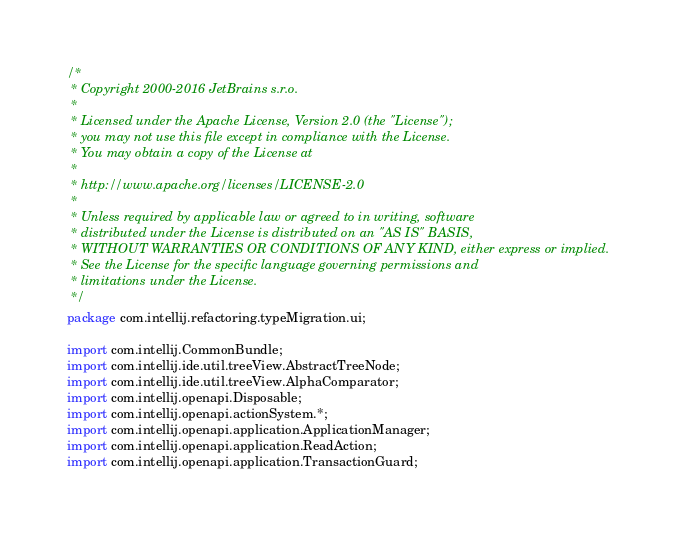<code> <loc_0><loc_0><loc_500><loc_500><_Java_>/*
 * Copyright 2000-2016 JetBrains s.r.o.
 *
 * Licensed under the Apache License, Version 2.0 (the "License");
 * you may not use this file except in compliance with the License.
 * You may obtain a copy of the License at
 *
 * http://www.apache.org/licenses/LICENSE-2.0
 *
 * Unless required by applicable law or agreed to in writing, software
 * distributed under the License is distributed on an "AS IS" BASIS,
 * WITHOUT WARRANTIES OR CONDITIONS OF ANY KIND, either express or implied.
 * See the License for the specific language governing permissions and
 * limitations under the License.
 */
package com.intellij.refactoring.typeMigration.ui;

import com.intellij.CommonBundle;
import com.intellij.ide.util.treeView.AbstractTreeNode;
import com.intellij.ide.util.treeView.AlphaComparator;
import com.intellij.openapi.Disposable;
import com.intellij.openapi.actionSystem.*;
import com.intellij.openapi.application.ApplicationManager;
import com.intellij.openapi.application.ReadAction;
import com.intellij.openapi.application.TransactionGuard;</code> 